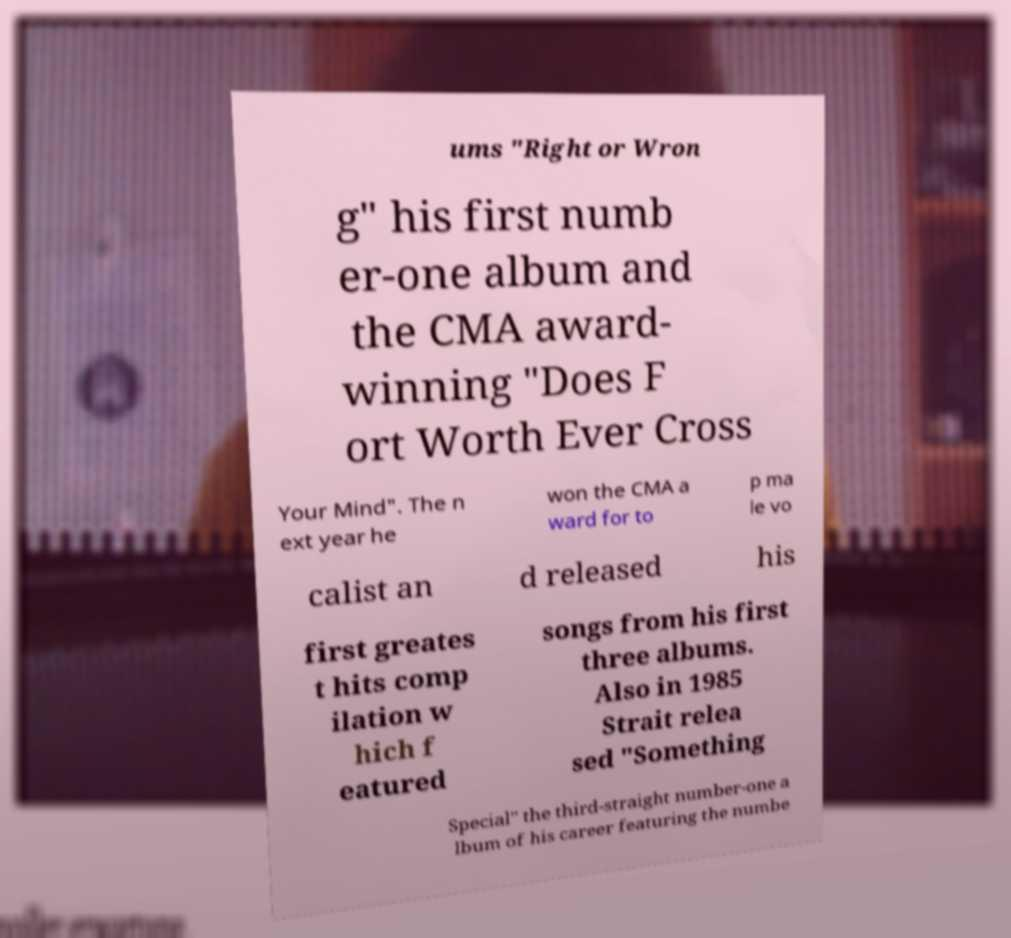Please read and relay the text visible in this image. What does it say? ums "Right or Wron g" his first numb er-one album and the CMA award- winning "Does F ort Worth Ever Cross Your Mind". The n ext year he won the CMA a ward for to p ma le vo calist an d released his first greates t hits comp ilation w hich f eatured songs from his first three albums. Also in 1985 Strait relea sed "Something Special" the third-straight number-one a lbum of his career featuring the numbe 